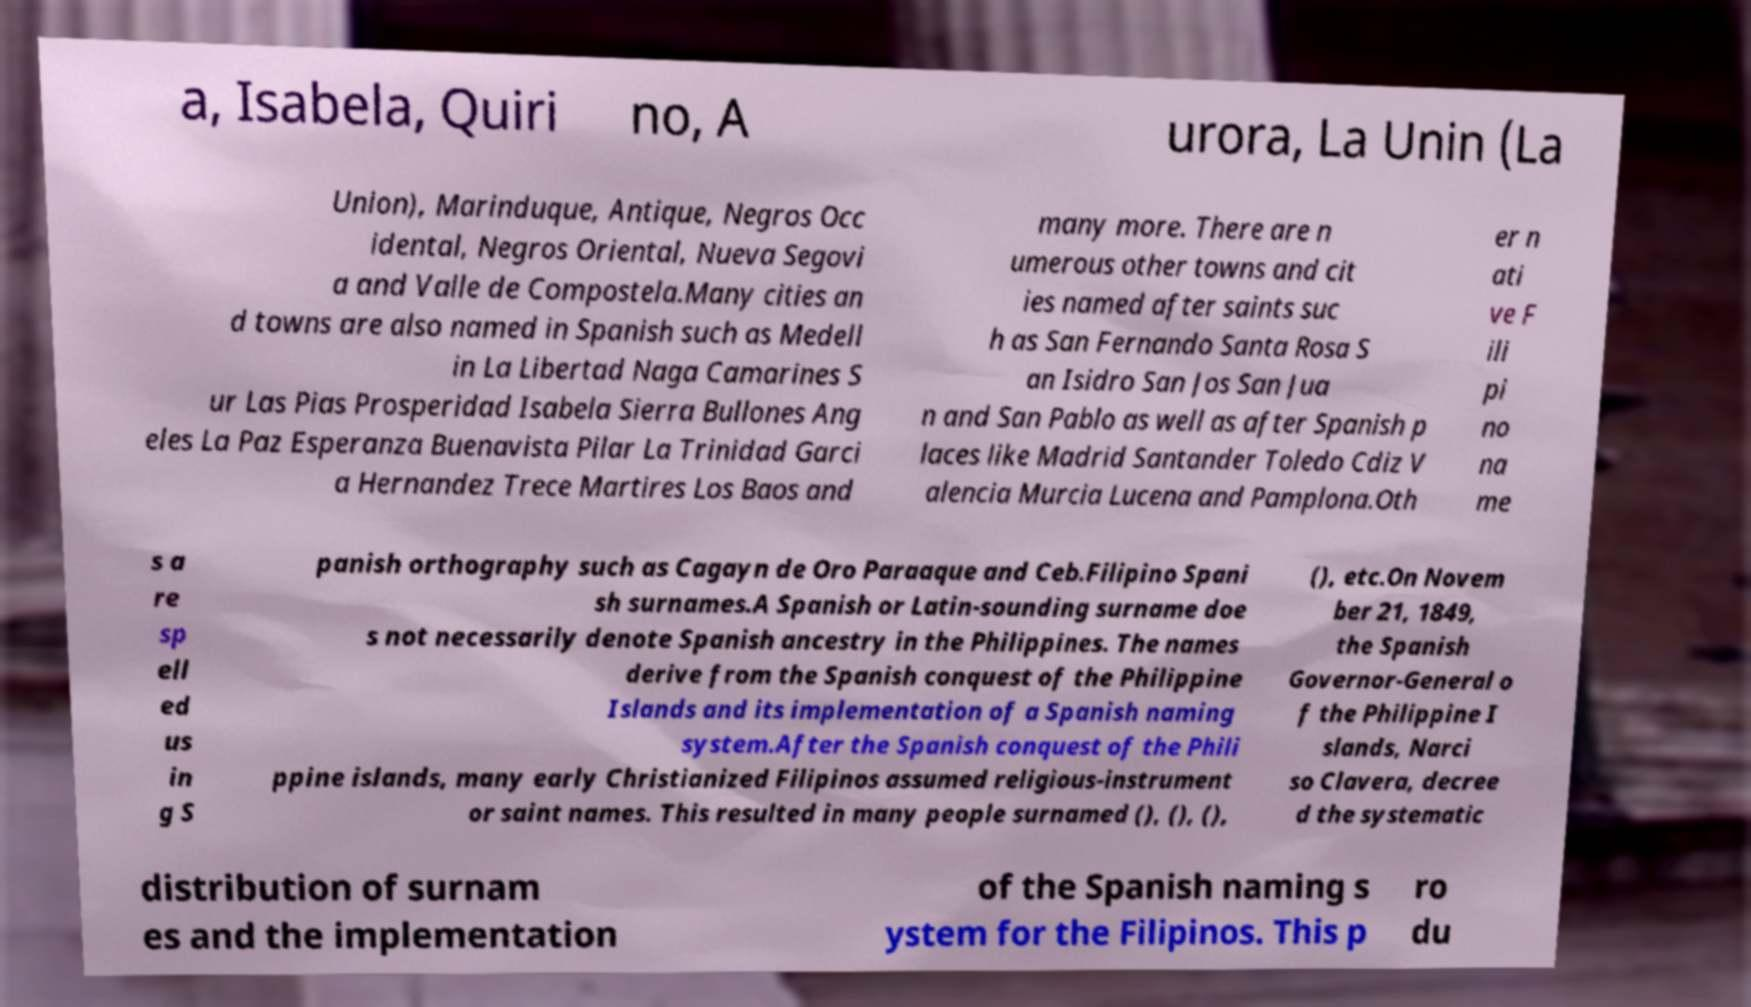Could you assist in decoding the text presented in this image and type it out clearly? a, Isabela, Quiri no, A urora, La Unin (La Union), Marinduque, Antique, Negros Occ idental, Negros Oriental, Nueva Segovi a and Valle de Compostela.Many cities an d towns are also named in Spanish such as Medell in La Libertad Naga Camarines S ur Las Pias Prosperidad Isabela Sierra Bullones Ang eles La Paz Esperanza Buenavista Pilar La Trinidad Garci a Hernandez Trece Martires Los Baos and many more. There are n umerous other towns and cit ies named after saints suc h as San Fernando Santa Rosa S an Isidro San Jos San Jua n and San Pablo as well as after Spanish p laces like Madrid Santander Toledo Cdiz V alencia Murcia Lucena and Pamplona.Oth er n ati ve F ili pi no na me s a re sp ell ed us in g S panish orthography such as Cagayn de Oro Paraaque and Ceb.Filipino Spani sh surnames.A Spanish or Latin-sounding surname doe s not necessarily denote Spanish ancestry in the Philippines. The names derive from the Spanish conquest of the Philippine Islands and its implementation of a Spanish naming system.After the Spanish conquest of the Phili ppine islands, many early Christianized Filipinos assumed religious-instrument or saint names. This resulted in many people surnamed (), (), (), (), etc.On Novem ber 21, 1849, the Spanish Governor-General o f the Philippine I slands, Narci so Clavera, decree d the systematic distribution of surnam es and the implementation of the Spanish naming s ystem for the Filipinos. This p ro du 